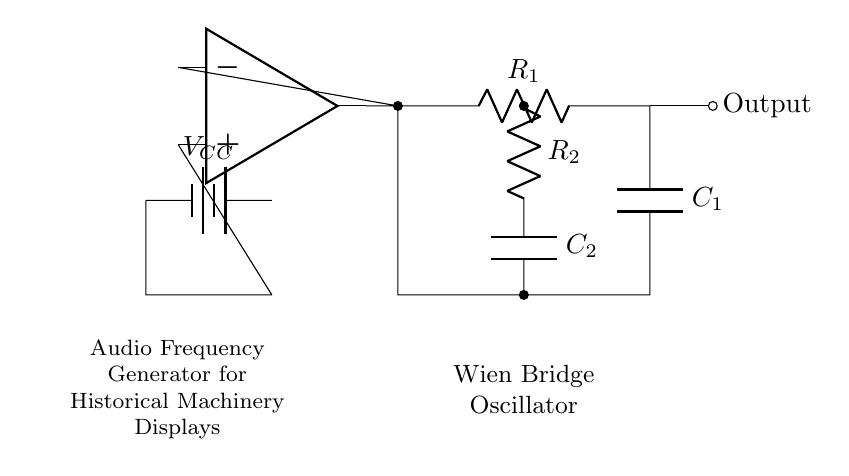What type of oscillator is shown in the circuit? The circuit is labeled as a Wien Bridge Oscillator, which uses a specific configuration of resistors and capacitors to generate oscillations.
Answer: Wien Bridge Oscillator Which components are responsible for frequency generation? The frequency generation typically depends on the combination of resistors and capacitors, specifically R1, R2, C1, and C2 in this diagram.
Answer: R1, R2, C1, C2 What is the power supply voltage applied in this circuit? The circuit includes a battery labeled VCC, which is the source of power for the operational amplifier and the entire circuit. The value is not specified but is indicated as VCC.
Answer: VCC How many capacitors are present in the circuit? The circuit diagram includes two capacitors, C1 and C2, as indicated by their labels.
Answer: Two What role does the operational amplifier play in this circuit? The operational amplifier in a Wien Bridge Oscillator serves as a gain element to sustain oscillations and amplify the feedback signal, critical for generating a continuous waveform.
Answer: Gain element What is the output connection of the oscillator? The output of the oscillator is marked and leads from the junction of components, where the output waveform can be measured or taken for use.
Answer: Output 